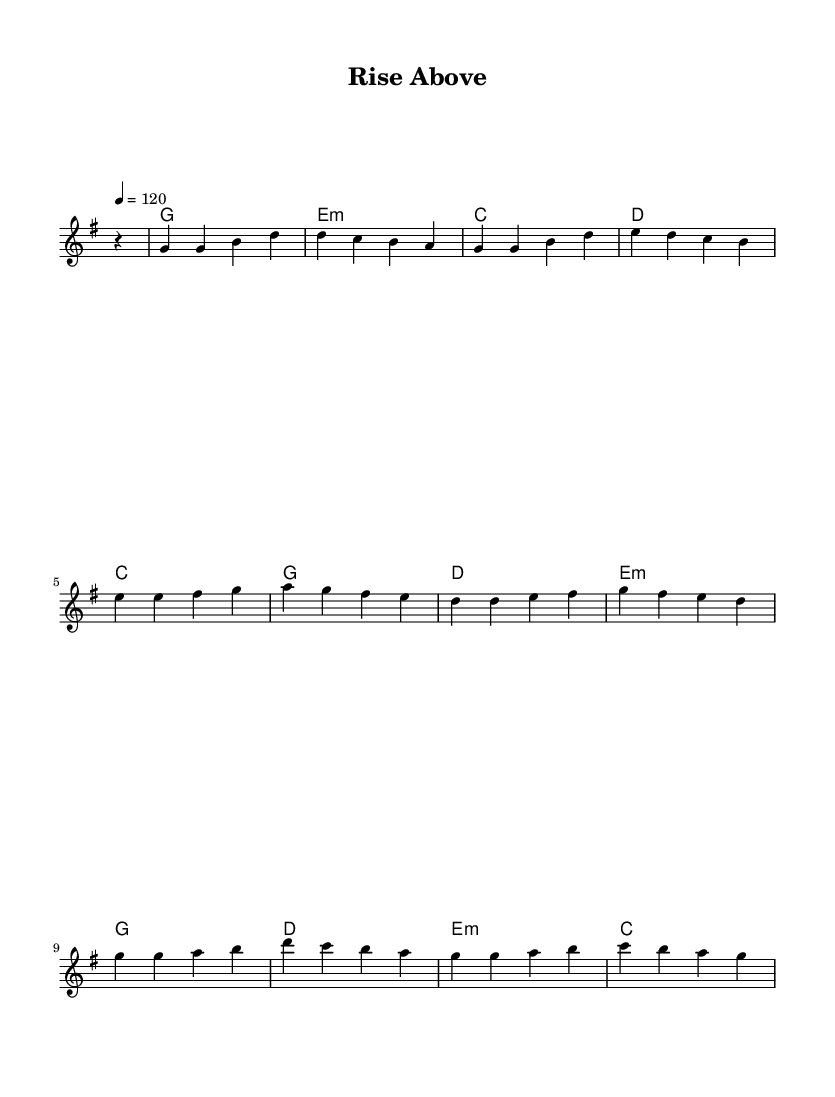What is the key signature of this music? The key signature is G major, which has one sharp (F#). This can be identified in the global section where \key g \major is specified.
Answer: G major What is the time signature of this music? The time signature is 4/4, which indicates there are four beats in each measure. This is also specified in the global section where \time 4/4 is stated.
Answer: 4/4 What is the tempo marking for this piece? The tempo marking is 120 beats per minute. This is shown as "4 = 120" in the global section.
Answer: 120 How many measures are in the chorus section? The chorus section has four measures, which can be counted as there are four groups of notes represented before the double vertical bar.
Answer: 4 What is the type of harmony used throughout the piece? The harmony primarily consists of major and minor chords. Analyzing the harmonies, we see G major, E minor, C major, D major, and E minor chords are used.
Answer: Major and minor chords Which section contains the highest pitch note? The highest pitch note in the given melody is B, which appears in both the chorus and verses. Looking at the melody, B is represented in multiple places.
Answer: B What can be inferred about the song's overall theme based on the title? The title "Rise Above" suggests a theme of overcoming challenges, which aligns with uplifting pop anthems. This can be inferred from typical pop themes of resilience and success.
Answer: Overcoming challenges 